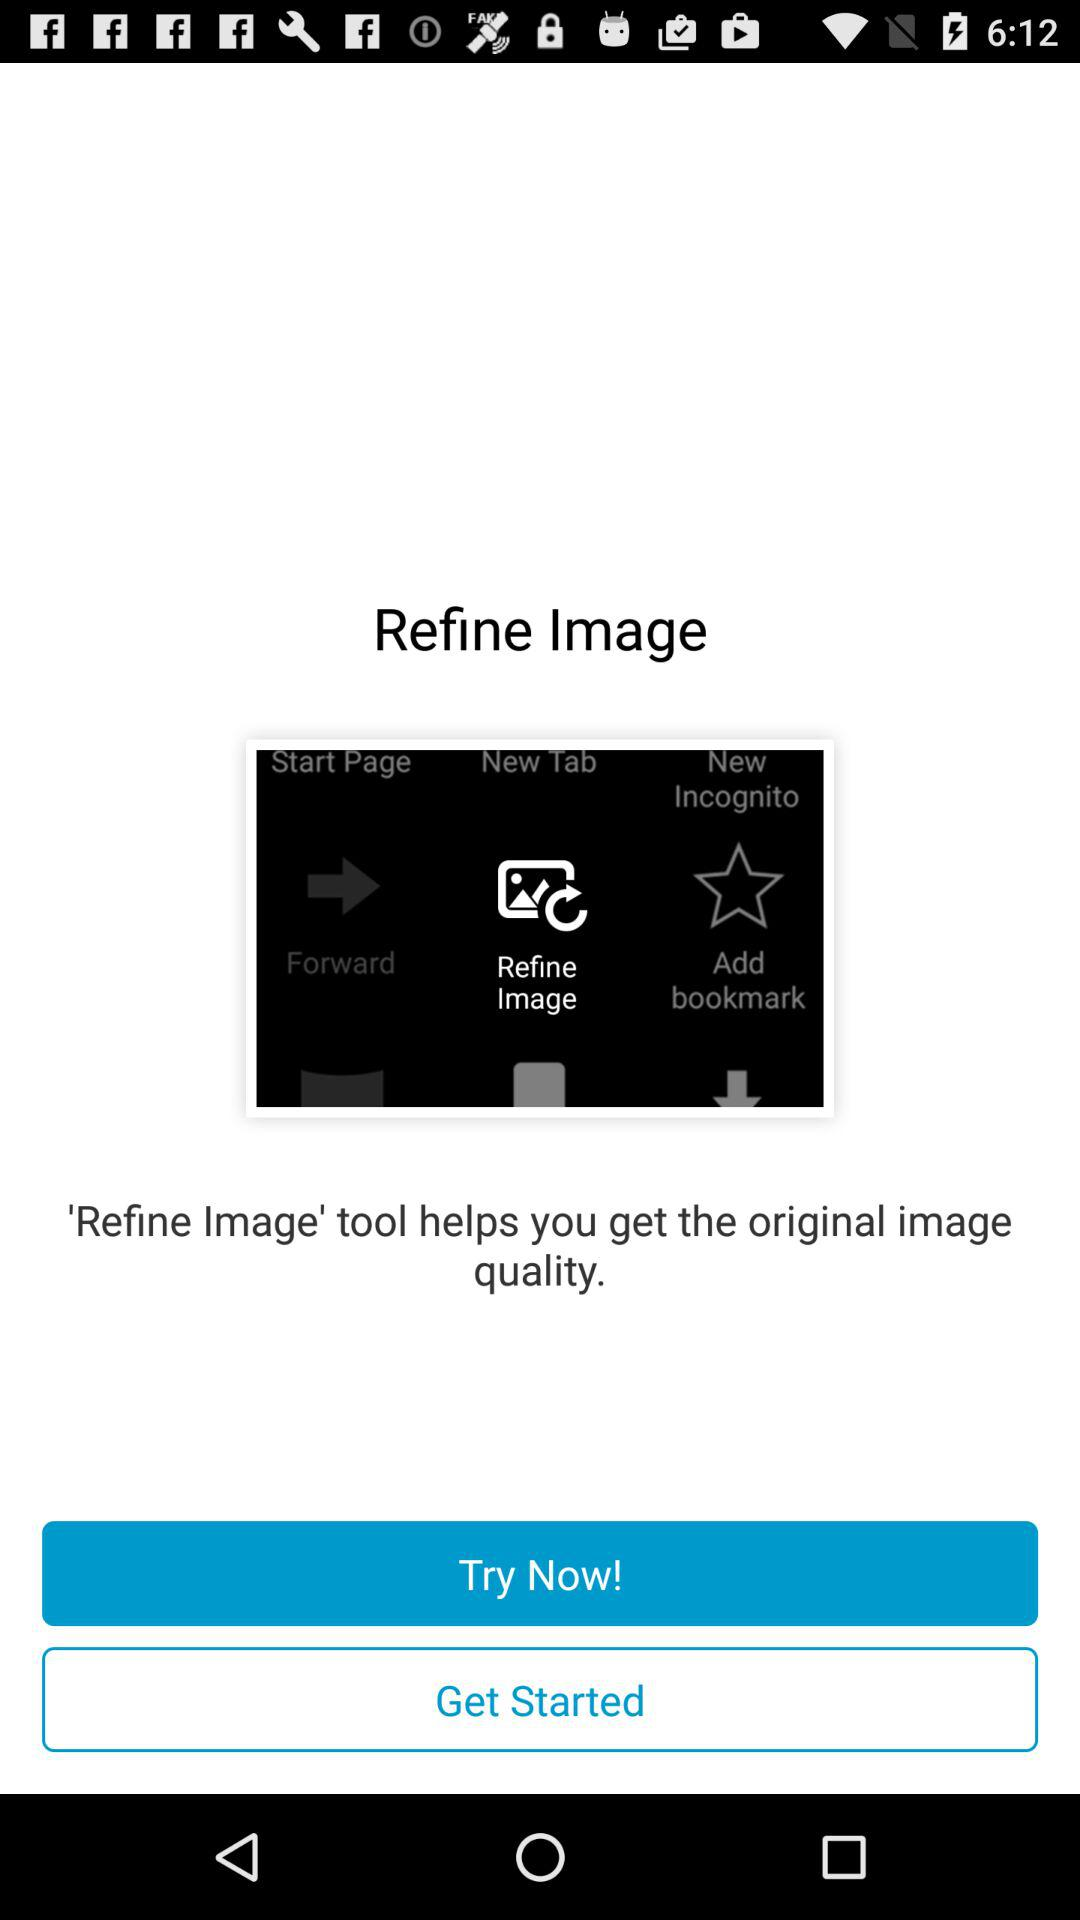Is the "Refine Image" tool equipped or not?
When the provided information is insufficient, respond with <no answer>. <no answer> 